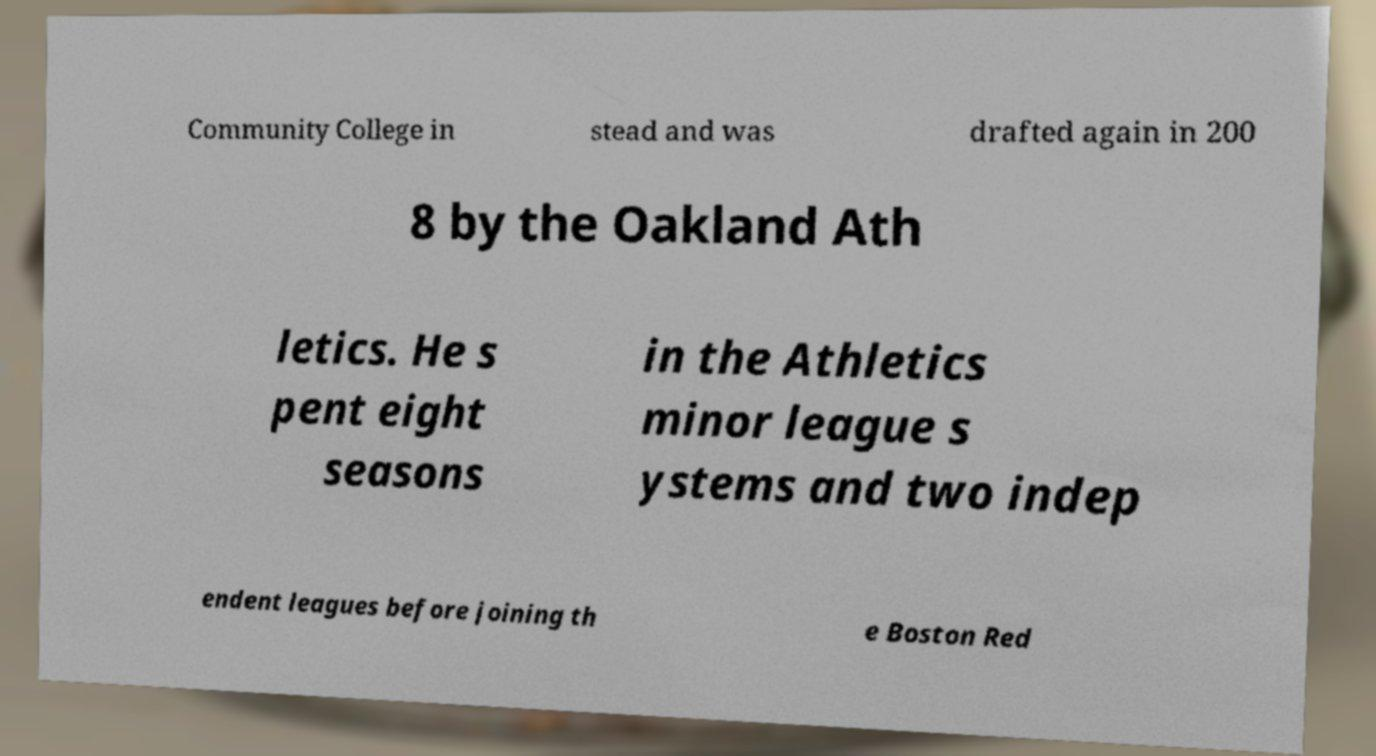What messages or text are displayed in this image? I need them in a readable, typed format. Community College in stead and was drafted again in 200 8 by the Oakland Ath letics. He s pent eight seasons in the Athletics minor league s ystems and two indep endent leagues before joining th e Boston Red 